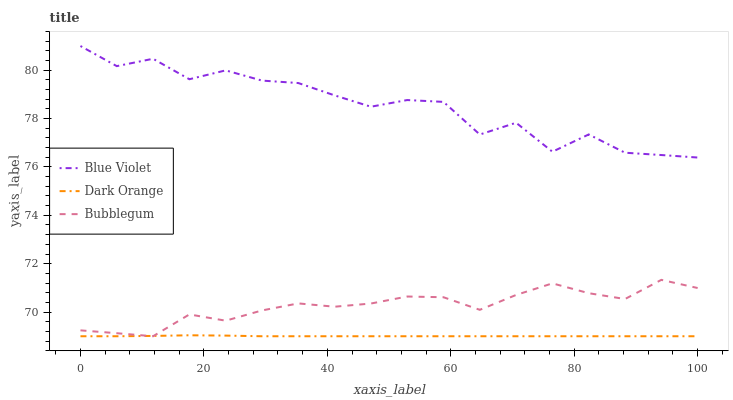Does Dark Orange have the minimum area under the curve?
Answer yes or no. Yes. Does Blue Violet have the maximum area under the curve?
Answer yes or no. Yes. Does Bubblegum have the minimum area under the curve?
Answer yes or no. No. Does Bubblegum have the maximum area under the curve?
Answer yes or no. No. Is Dark Orange the smoothest?
Answer yes or no. Yes. Is Blue Violet the roughest?
Answer yes or no. Yes. Is Bubblegum the smoothest?
Answer yes or no. No. Is Bubblegum the roughest?
Answer yes or no. No. Does Blue Violet have the lowest value?
Answer yes or no. No. Does Blue Violet have the highest value?
Answer yes or no. Yes. Does Bubblegum have the highest value?
Answer yes or no. No. Is Bubblegum less than Blue Violet?
Answer yes or no. Yes. Is Blue Violet greater than Bubblegum?
Answer yes or no. Yes. Does Dark Orange intersect Bubblegum?
Answer yes or no. Yes. Is Dark Orange less than Bubblegum?
Answer yes or no. No. Is Dark Orange greater than Bubblegum?
Answer yes or no. No. Does Bubblegum intersect Blue Violet?
Answer yes or no. No. 